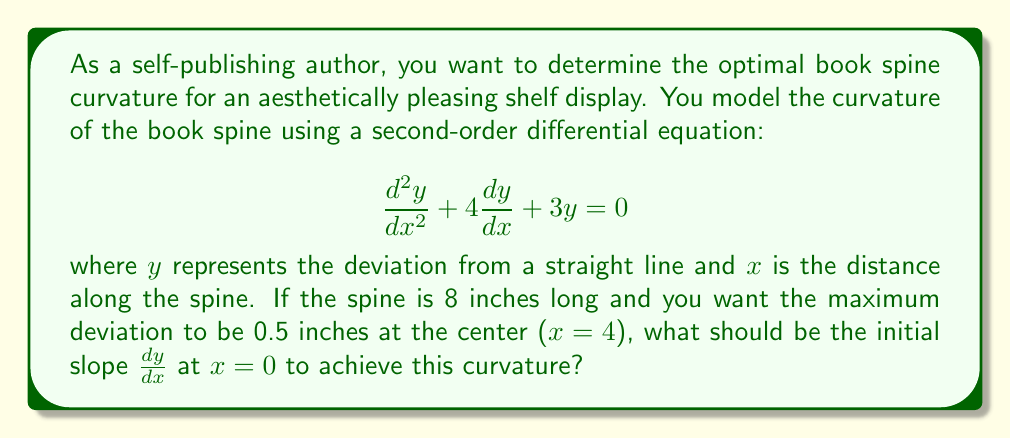Help me with this question. To solve this problem, we need to follow these steps:

1) The general solution for this second-order linear equation is:
   $$y = c_1e^{-x} + c_2e^{-3x}$$

2) We need to find $c_1$ and $c_2$ using the given conditions:
   - At x = 4, y = 0.5 (maximum deviation at center)
   - At x = 0, y = 0 (spine starts straight)

3) Using the second condition:
   $$0 = c_1 + c_2$$
   $$c_2 = -c_1$$

4) Using the first condition:
   $$0.5 = c_1e^{-4} + c_2e^{-12}$$
   $$0.5 = c_1e^{-4} - c_1e^{-12}$$
   $$0.5 = c_1(e^{-4} - e^{-12})$$
   $$c_1 = \frac{0.5}{e^{-4} - e^{-12}} \approx 0.5411$$

5) Therefore, $c_2 \approx -0.5411$

6) Now, to find the initial slope, we differentiate y:
   $$\frac{dy}{dx} = -c_1e^{-x} - 3c_2e^{-3x}$$

7) At x = 0:
   $$\left.\frac{dy}{dx}\right|_{x=0} = -c_1 - 3c_2$$
   $$= -0.5411 - 3(-0.5411)$$
   $$= 1.0822$$

Therefore, the initial slope should be approximately 1.0822.
Answer: The initial slope $\frac{dy}{dx}$ at x = 0 should be approximately 1.0822 to achieve the desired curvature. 